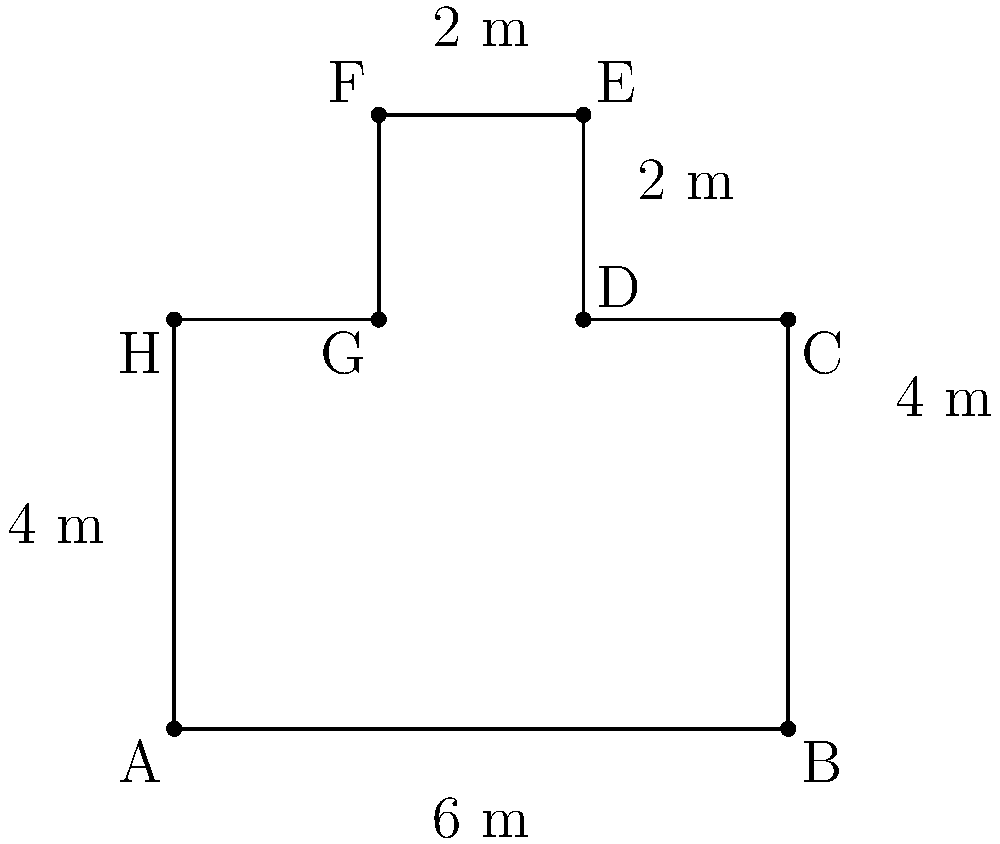You're hiking in Snow Canyon State Park and come across an interesting cross-section of a sandstone formation. The cross-section has an irregular shape that can be approximated by the figure shown above. If the measurements are as indicated in the diagram, what is the total area of this cross-section in square meters? To find the total area of the cross-section, we can break it down into simpler shapes:

1. The main rectangle (ABCH):
   Area = 6 m × 4 m = 24 m²

2. The upper left rectangle (HEFG):
   Area = 2 m × 2 m = 4 m²

3. The upper right rectangle (CDEF):
   Area = 2 m × 2 m = 4 m²

Now, let's add these areas together:

Total Area = Area of ABCH + Area of HEFG + Area of CDEF
           = 24 m² + 4 m² + 4 m²
           = 32 m²

Therefore, the total area of the cross-section is 32 square meters.
Answer: 32 m² 